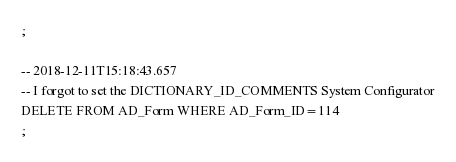Convert code to text. <code><loc_0><loc_0><loc_500><loc_500><_SQL_>;

-- 2018-12-11T15:18:43.657
-- I forgot to set the DICTIONARY_ID_COMMENTS System Configurator
DELETE FROM AD_Form WHERE AD_Form_ID=114
;

</code> 